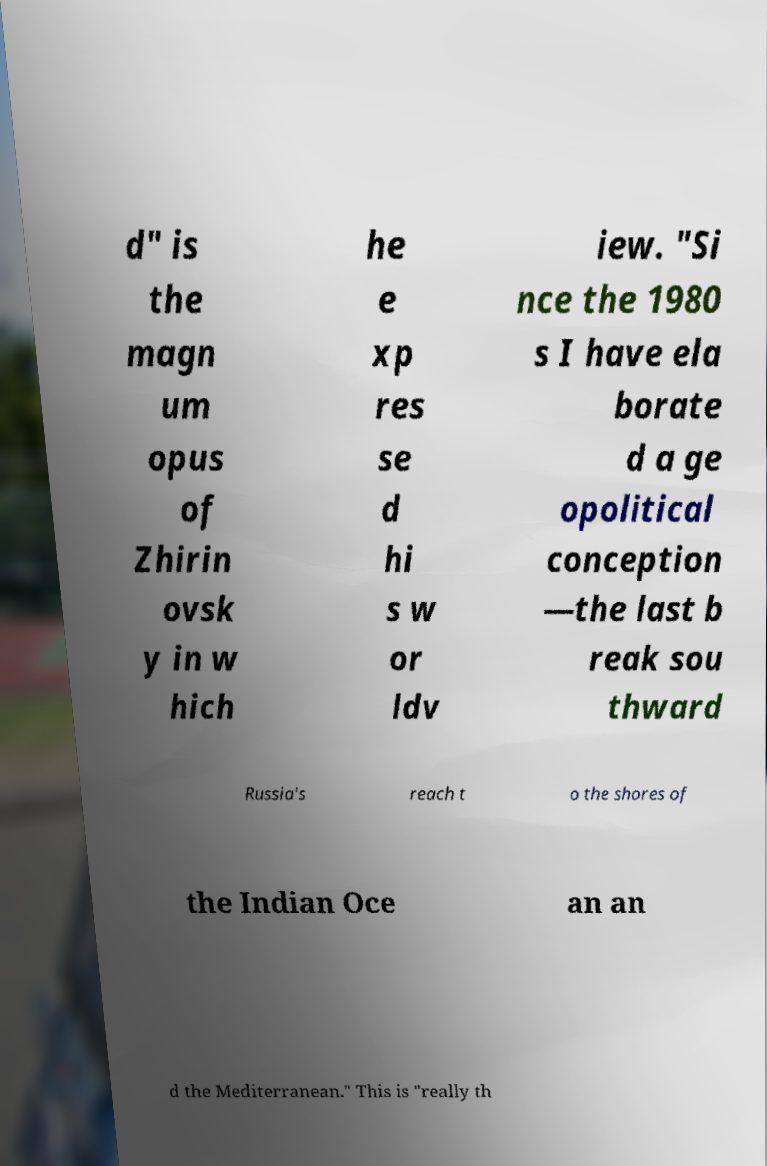Can you read and provide the text displayed in the image?This photo seems to have some interesting text. Can you extract and type it out for me? d" is the magn um opus of Zhirin ovsk y in w hich he e xp res se d hi s w or ldv iew. "Si nce the 1980 s I have ela borate d a ge opolitical conception —the last b reak sou thward Russia's reach t o the shores of the Indian Oce an an d the Mediterranean." This is "really th 